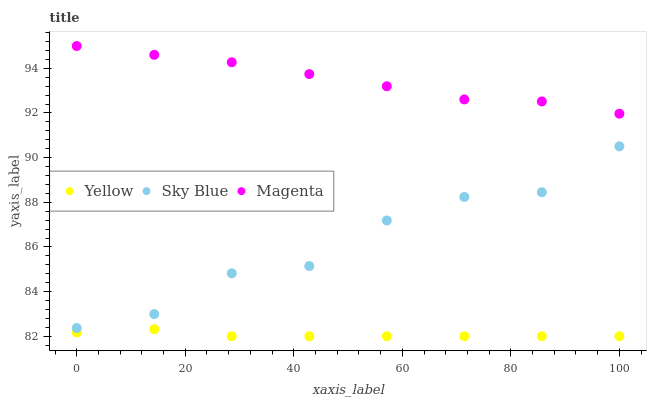Does Yellow have the minimum area under the curve?
Answer yes or no. Yes. Does Magenta have the maximum area under the curve?
Answer yes or no. Yes. Does Magenta have the minimum area under the curve?
Answer yes or no. No. Does Yellow have the maximum area under the curve?
Answer yes or no. No. Is Yellow the smoothest?
Answer yes or no. Yes. Is Sky Blue the roughest?
Answer yes or no. Yes. Is Magenta the smoothest?
Answer yes or no. No. Is Magenta the roughest?
Answer yes or no. No. Does Yellow have the lowest value?
Answer yes or no. Yes. Does Magenta have the lowest value?
Answer yes or no. No. Does Magenta have the highest value?
Answer yes or no. Yes. Does Yellow have the highest value?
Answer yes or no. No. Is Sky Blue less than Magenta?
Answer yes or no. Yes. Is Magenta greater than Yellow?
Answer yes or no. Yes. Does Sky Blue intersect Magenta?
Answer yes or no. No. 